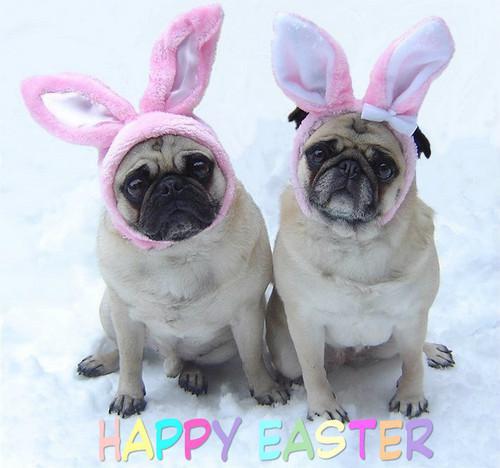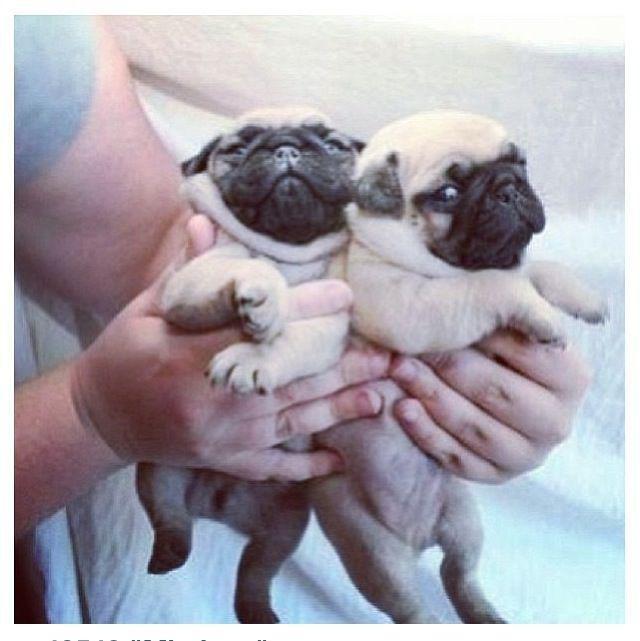The first image is the image on the left, the second image is the image on the right. Assess this claim about the two images: "two pugs are wearing costumes". Correct or not? Answer yes or no. Yes. 